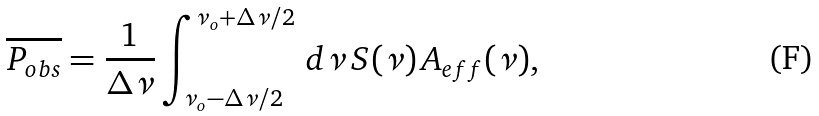Convert formula to latex. <formula><loc_0><loc_0><loc_500><loc_500>\overline { P _ { o b s } } = \frac { 1 } { \Delta \nu } \int _ { \nu _ { o } - \Delta \nu / 2 } ^ { \nu _ { o } + \Delta \nu / 2 } \, d \nu \, S ( \nu ) \, A _ { e f f } ( \nu ) ,</formula> 